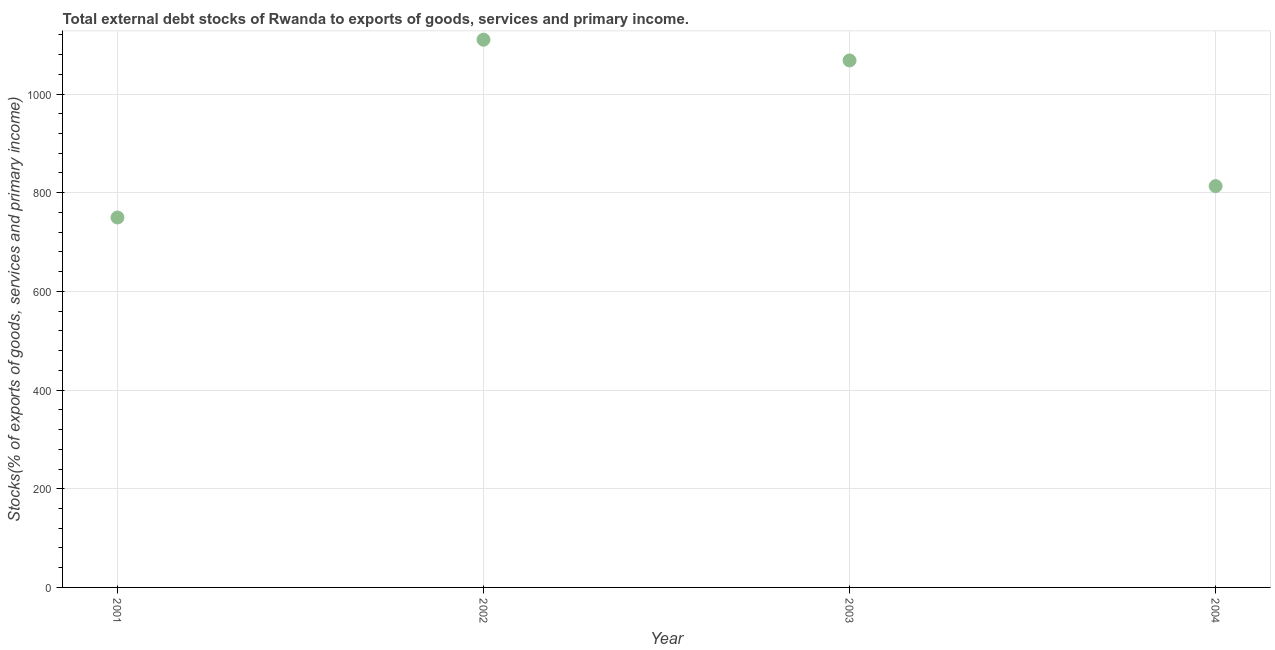What is the external debt stocks in 2001?
Your answer should be compact. 749.79. Across all years, what is the maximum external debt stocks?
Your response must be concise. 1110.12. Across all years, what is the minimum external debt stocks?
Your answer should be very brief. 749.79. In which year was the external debt stocks maximum?
Keep it short and to the point. 2002. In which year was the external debt stocks minimum?
Provide a succinct answer. 2001. What is the sum of the external debt stocks?
Provide a short and direct response. 3741.42. What is the difference between the external debt stocks in 2001 and 2004?
Your response must be concise. -63.61. What is the average external debt stocks per year?
Keep it short and to the point. 935.35. What is the median external debt stocks?
Provide a short and direct response. 940.75. In how many years, is the external debt stocks greater than 560 %?
Provide a succinct answer. 4. Do a majority of the years between 2003 and 2001 (inclusive) have external debt stocks greater than 1080 %?
Offer a terse response. No. What is the ratio of the external debt stocks in 2002 to that in 2003?
Provide a short and direct response. 1.04. What is the difference between the highest and the second highest external debt stocks?
Provide a succinct answer. 42.03. What is the difference between the highest and the lowest external debt stocks?
Make the answer very short. 360.33. Does the external debt stocks monotonically increase over the years?
Make the answer very short. No. How many dotlines are there?
Your answer should be very brief. 1. Are the values on the major ticks of Y-axis written in scientific E-notation?
Your answer should be very brief. No. Does the graph contain any zero values?
Keep it short and to the point. No. Does the graph contain grids?
Make the answer very short. Yes. What is the title of the graph?
Your answer should be compact. Total external debt stocks of Rwanda to exports of goods, services and primary income. What is the label or title of the X-axis?
Offer a terse response. Year. What is the label or title of the Y-axis?
Provide a short and direct response. Stocks(% of exports of goods, services and primary income). What is the Stocks(% of exports of goods, services and primary income) in 2001?
Your answer should be compact. 749.79. What is the Stocks(% of exports of goods, services and primary income) in 2002?
Your response must be concise. 1110.12. What is the Stocks(% of exports of goods, services and primary income) in 2003?
Make the answer very short. 1068.1. What is the Stocks(% of exports of goods, services and primary income) in 2004?
Provide a short and direct response. 813.4. What is the difference between the Stocks(% of exports of goods, services and primary income) in 2001 and 2002?
Provide a short and direct response. -360.33. What is the difference between the Stocks(% of exports of goods, services and primary income) in 2001 and 2003?
Keep it short and to the point. -318.31. What is the difference between the Stocks(% of exports of goods, services and primary income) in 2001 and 2004?
Ensure brevity in your answer.  -63.61. What is the difference between the Stocks(% of exports of goods, services and primary income) in 2002 and 2003?
Your answer should be compact. 42.03. What is the difference between the Stocks(% of exports of goods, services and primary income) in 2002 and 2004?
Offer a very short reply. 296.72. What is the difference between the Stocks(% of exports of goods, services and primary income) in 2003 and 2004?
Offer a very short reply. 254.7. What is the ratio of the Stocks(% of exports of goods, services and primary income) in 2001 to that in 2002?
Your answer should be very brief. 0.68. What is the ratio of the Stocks(% of exports of goods, services and primary income) in 2001 to that in 2003?
Your response must be concise. 0.7. What is the ratio of the Stocks(% of exports of goods, services and primary income) in 2001 to that in 2004?
Give a very brief answer. 0.92. What is the ratio of the Stocks(% of exports of goods, services and primary income) in 2002 to that in 2003?
Your answer should be compact. 1.04. What is the ratio of the Stocks(% of exports of goods, services and primary income) in 2002 to that in 2004?
Offer a terse response. 1.36. What is the ratio of the Stocks(% of exports of goods, services and primary income) in 2003 to that in 2004?
Give a very brief answer. 1.31. 